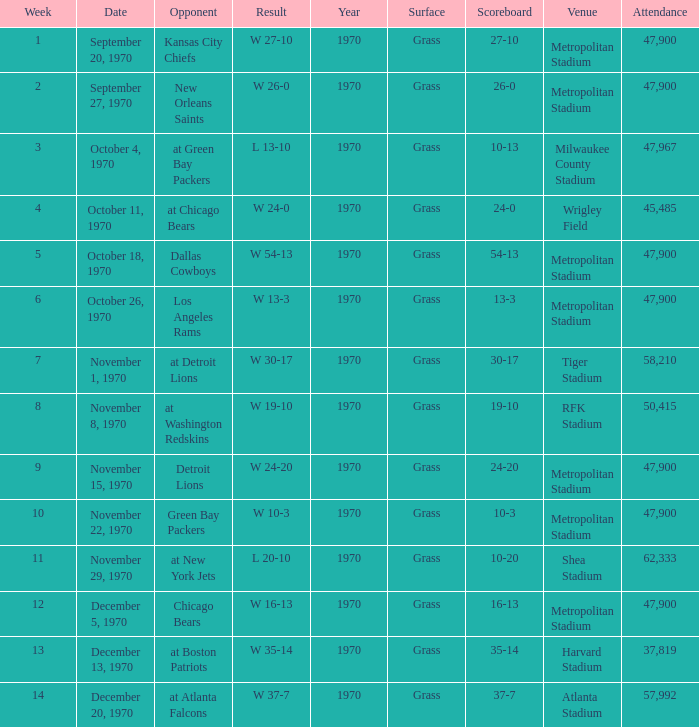How many people attended the game with a result of w 16-13 and a week earlier than 12? None. 